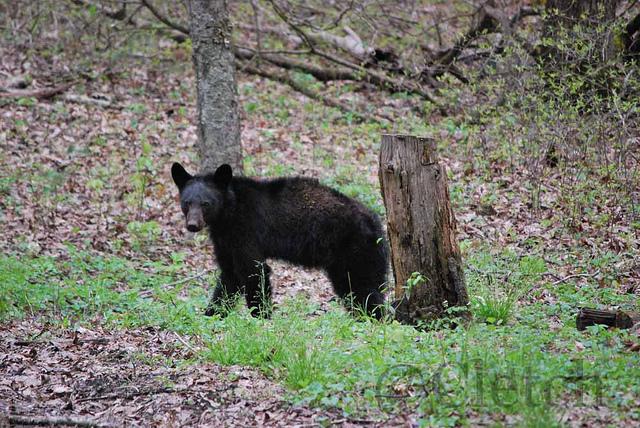What kind of bear is this?
Keep it brief. Black. Is this a young bear?
Answer briefly. Yes. What part of the bear's body is hidden behind a tree?
Quick response, please. Tail. Is the bear in the wild?
Quick response, please. Yes. 